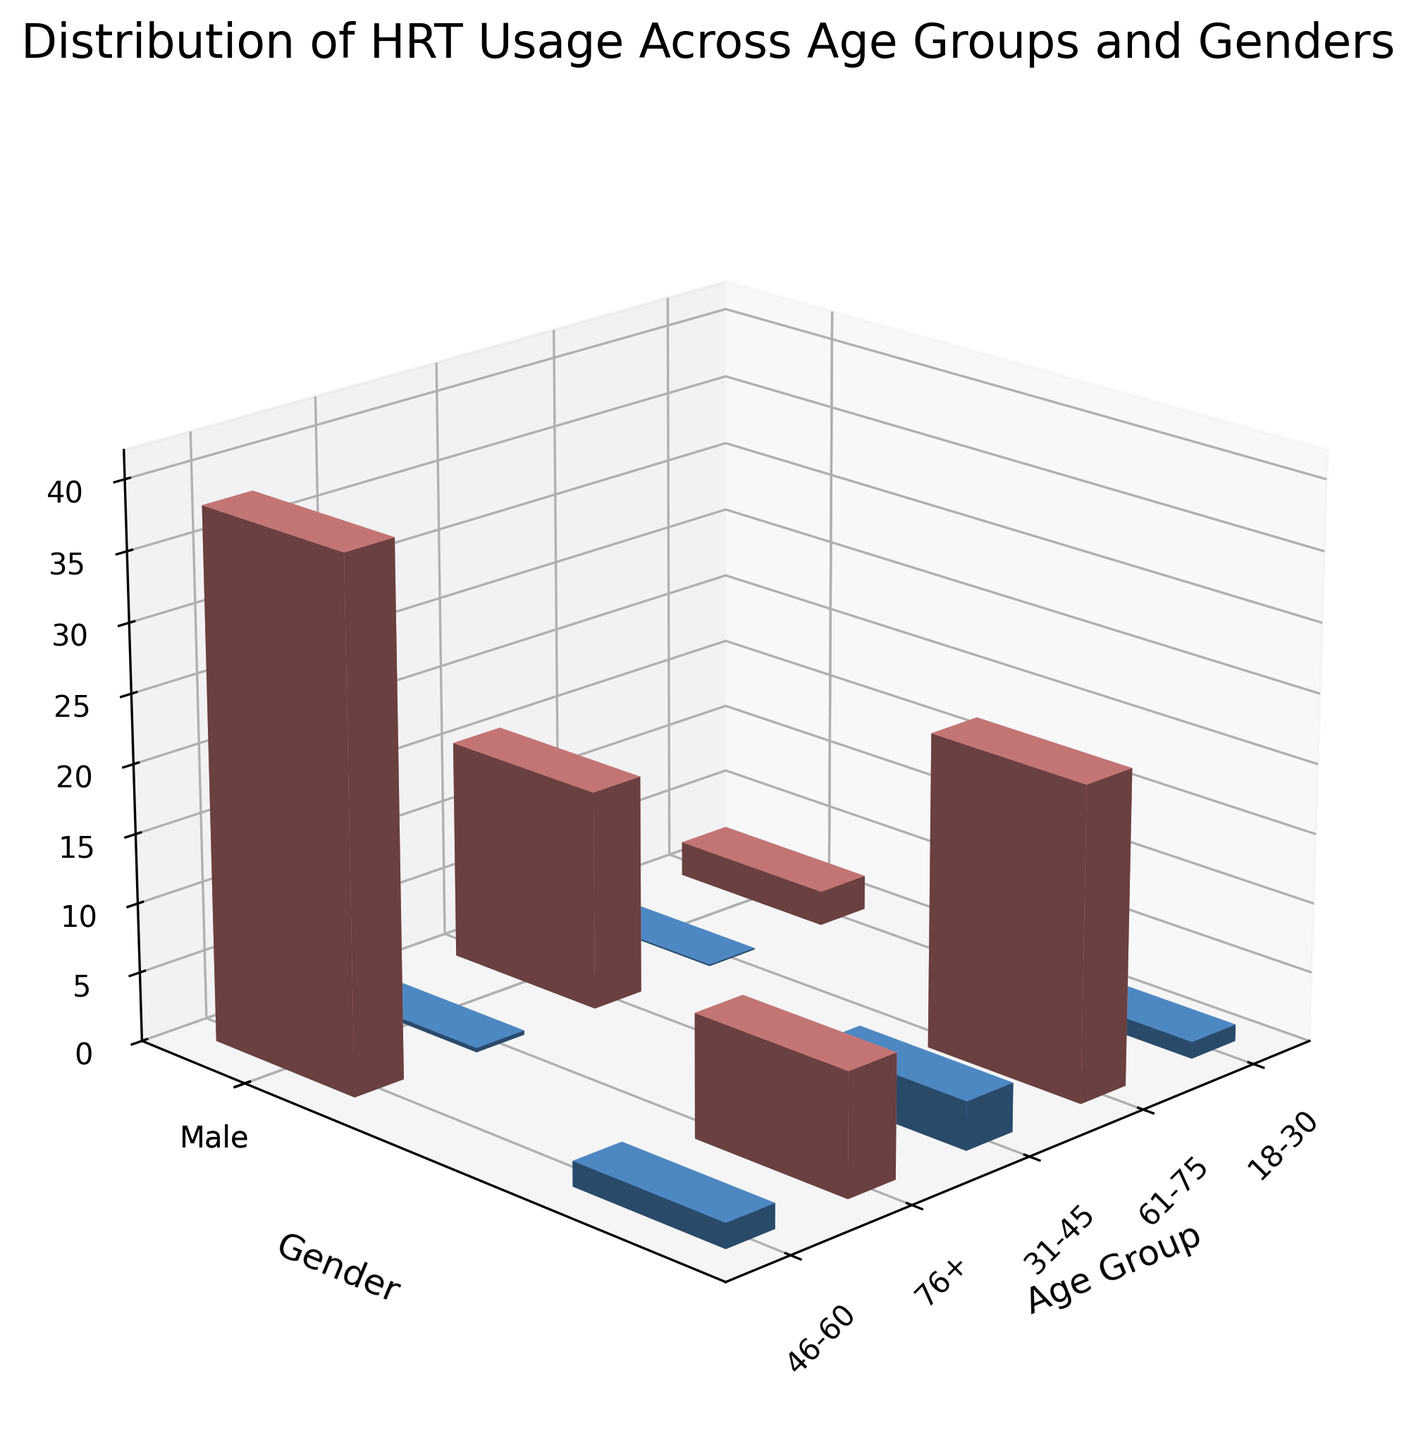How many age groups are represented in the figure? The x-axis of the figure shows the age groups represented. Count the distinct labels on the x-axis.
Answer: 5 What is the HRT usage percentage for females aged 46-60? Look at the bar corresponding to females (y-axis) and the age group 46-60 (x-axis). The height of the bar indicates the HRT usage percentage.
Answer: 38.2% Which gender has greater HRT usage in the age group 61-75? Compare the heights of the two bars (one for males and one for females) in the age group 61-75. The taller bar represents the gender with greater HRT usage.
Answer: Female What is the title of the figure? The title is generally located at the top of the figure.
Answer: Distribution of HRT Usage Across Age Groups and Genders Which age group has the lowest HRT usage among females? Observe the bars labeled for females across different age groups, and identify the one with the smallest height.
Answer: 18-30 What is the difference in HRT usage percentage between males and females aged 76+? Locate the bars for both males and females in the 76+ age group and calculate the difference in their heights.
Answer: 7.1% What is the average HRT usage percentage for females across all age groups? Sum the HRT usage percentages for females in all age groups and divide by the number of age groups to get the average. (2.5 + 15.8 + 38.2 + 22.6 + 8.9) / 5 = 17.6
Answer: 17.6% How does the HRT usage percentage of males aged 18-30 compare to males aged 46-60? Compare the heights of the bars representing males in the 18-30 and 46-60 age groups.
Answer: Less What is the color of the bars representing females? The bars for females are colored differently from those for males. The particular color is consistent across all female bars.
Answer: Light Red Do males or females have a higher HRT usage on average across all age groups? Calculate the average HRT usage for each gender across all age groups. Compare the two averages. Males: (0.1 + 0.3 + 1.2 + 3.5 + 1.8) / 5 = 1.38, Females: 17.6
Answer: Females 